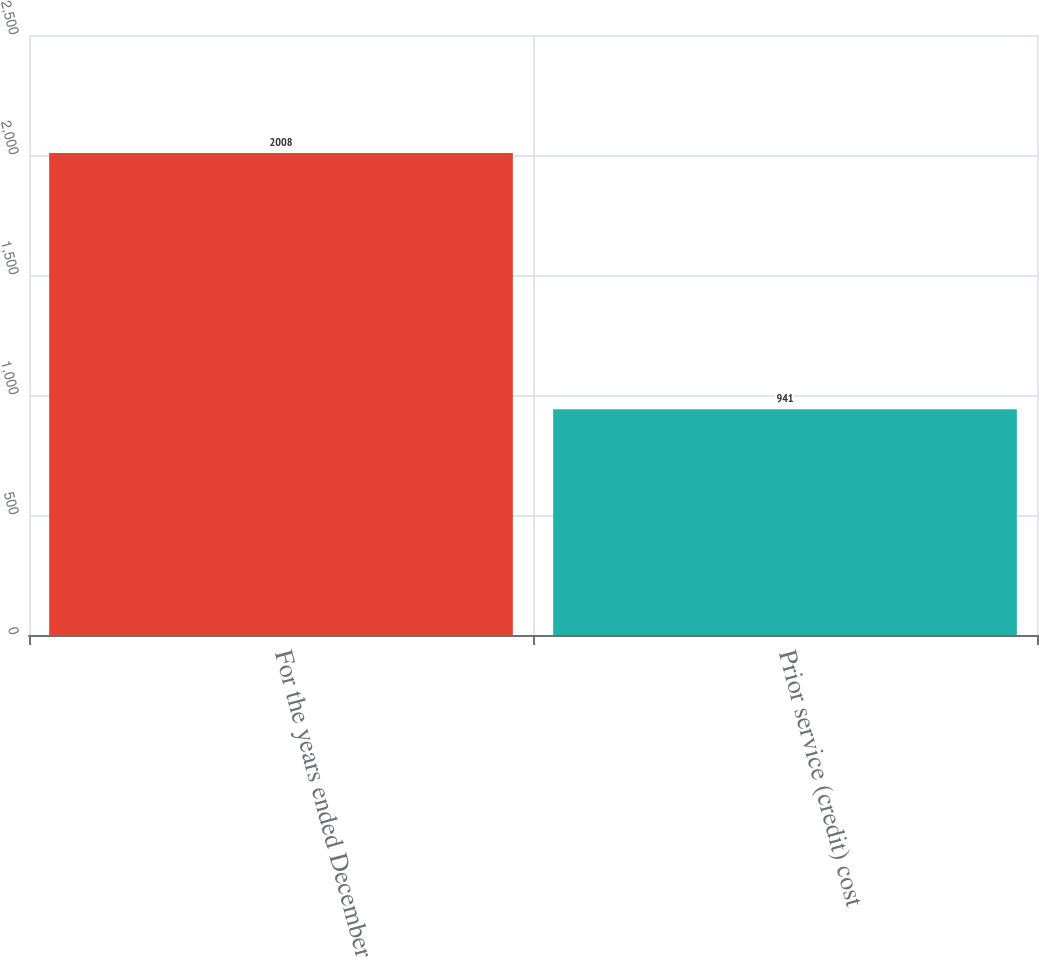Convert chart to OTSL. <chart><loc_0><loc_0><loc_500><loc_500><bar_chart><fcel>For the years ended December<fcel>Prior service (credit) cost<nl><fcel>2008<fcel>941<nl></chart> 